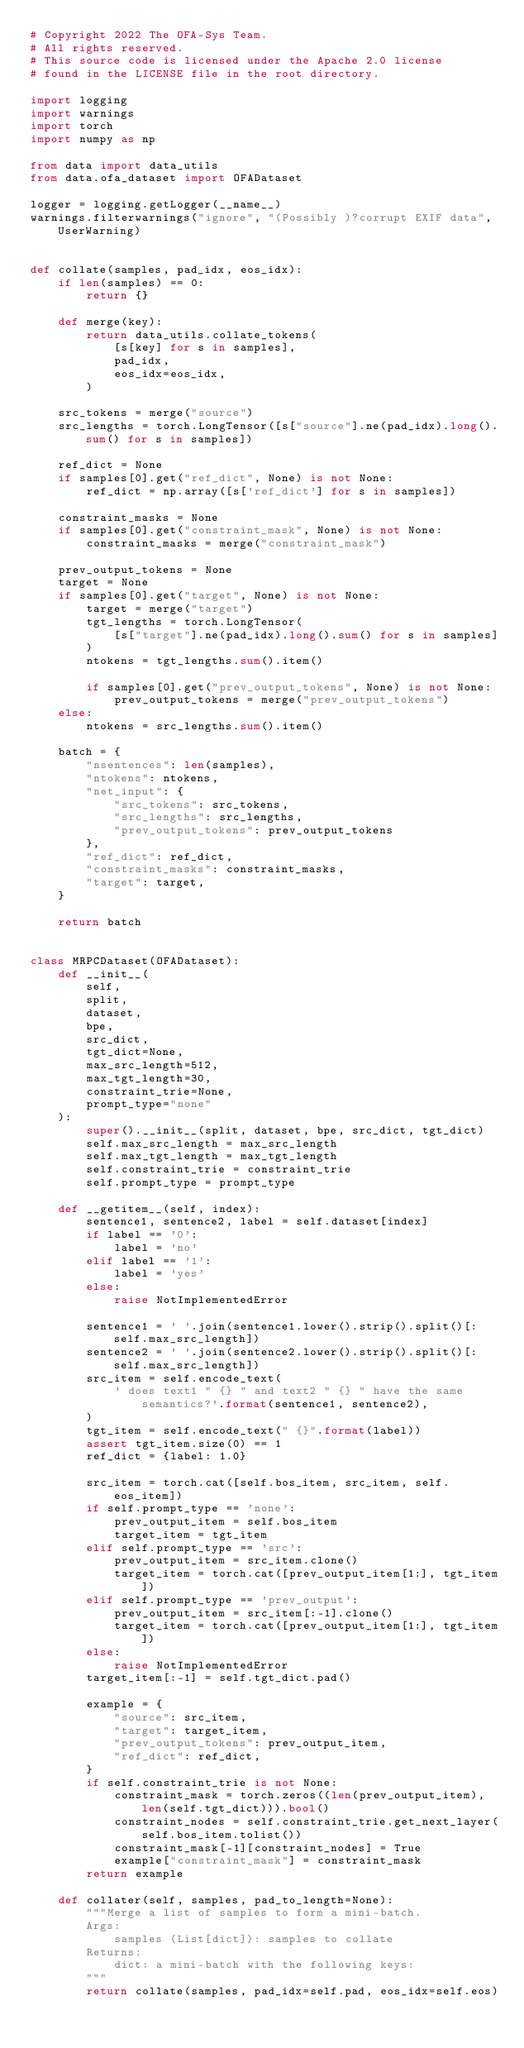Convert code to text. <code><loc_0><loc_0><loc_500><loc_500><_Python_># Copyright 2022 The OFA-Sys Team. 
# All rights reserved.
# This source code is licensed under the Apache 2.0 license 
# found in the LICENSE file in the root directory.

import logging
import warnings
import torch
import numpy as np

from data import data_utils
from data.ofa_dataset import OFADataset

logger = logging.getLogger(__name__)
warnings.filterwarnings("ignore", "(Possibly )?corrupt EXIF data", UserWarning)


def collate(samples, pad_idx, eos_idx):
    if len(samples) == 0:
        return {}

    def merge(key):
        return data_utils.collate_tokens(
            [s[key] for s in samples],
            pad_idx,
            eos_idx=eos_idx,
        )

    src_tokens = merge("source")
    src_lengths = torch.LongTensor([s["source"].ne(pad_idx).long().sum() for s in samples])

    ref_dict = None
    if samples[0].get("ref_dict", None) is not None:
        ref_dict = np.array([s['ref_dict'] for s in samples])

    constraint_masks = None
    if samples[0].get("constraint_mask", None) is not None:
        constraint_masks = merge("constraint_mask")

    prev_output_tokens = None
    target = None
    if samples[0].get("target", None) is not None:
        target = merge("target")
        tgt_lengths = torch.LongTensor(
            [s["target"].ne(pad_idx).long().sum() for s in samples]
        )
        ntokens = tgt_lengths.sum().item()

        if samples[0].get("prev_output_tokens", None) is not None:
            prev_output_tokens = merge("prev_output_tokens")
    else:
        ntokens = src_lengths.sum().item()

    batch = {
        "nsentences": len(samples),
        "ntokens": ntokens,
        "net_input": {
            "src_tokens": src_tokens,
            "src_lengths": src_lengths,
            "prev_output_tokens": prev_output_tokens
        },
        "ref_dict": ref_dict,
        "constraint_masks": constraint_masks,
        "target": target,
    }

    return batch


class MRPCDataset(OFADataset):
    def __init__(
        self,
        split,
        dataset,
        bpe,
        src_dict,
        tgt_dict=None,
        max_src_length=512,
        max_tgt_length=30,
        constraint_trie=None,
        prompt_type="none"
    ):
        super().__init__(split, dataset, bpe, src_dict, tgt_dict)
        self.max_src_length = max_src_length
        self.max_tgt_length = max_tgt_length
        self.constraint_trie = constraint_trie
        self.prompt_type = prompt_type

    def __getitem__(self, index):
        sentence1, sentence2, label = self.dataset[index]
        if label == '0':
            label = 'no'
        elif label == '1':
            label = 'yes'
        else:
            raise NotImplementedError

        sentence1 = ' '.join(sentence1.lower().strip().split()[:self.max_src_length])
        sentence2 = ' '.join(sentence2.lower().strip().split()[:self.max_src_length])
        src_item = self.encode_text(
            ' does text1 " {} " and text2 " {} " have the same semantics?'.format(sentence1, sentence2),
        )
        tgt_item = self.encode_text(" {}".format(label))
        assert tgt_item.size(0) == 1
        ref_dict = {label: 1.0}

        src_item = torch.cat([self.bos_item, src_item, self.eos_item])
        if self.prompt_type == 'none':
            prev_output_item = self.bos_item
            target_item = tgt_item
        elif self.prompt_type == 'src':
            prev_output_item = src_item.clone()
            target_item = torch.cat([prev_output_item[1:], tgt_item])
        elif self.prompt_type == 'prev_output':
            prev_output_item = src_item[:-1].clone()
            target_item = torch.cat([prev_output_item[1:], tgt_item])
        else:
            raise NotImplementedError
        target_item[:-1] = self.tgt_dict.pad()

        example = {
            "source": src_item,
            "target": target_item,
            "prev_output_tokens": prev_output_item,
            "ref_dict": ref_dict,
        }
        if self.constraint_trie is not None:
            constraint_mask = torch.zeros((len(prev_output_item), len(self.tgt_dict))).bool()
            constraint_nodes = self.constraint_trie.get_next_layer(self.bos_item.tolist())
            constraint_mask[-1][constraint_nodes] = True
            example["constraint_mask"] = constraint_mask
        return example

    def collater(self, samples, pad_to_length=None):
        """Merge a list of samples to form a mini-batch.
        Args:
            samples (List[dict]): samples to collate
        Returns:
            dict: a mini-batch with the following keys:
        """
        return collate(samples, pad_idx=self.pad, eos_idx=self.eos)
</code> 